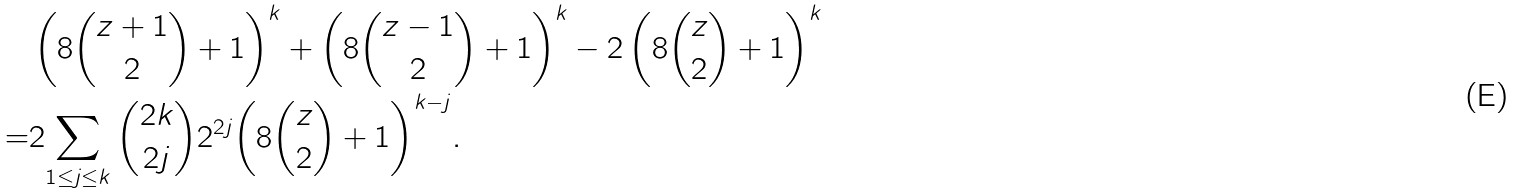Convert formula to latex. <formula><loc_0><loc_0><loc_500><loc_500>& \left ( 8 \binom { z + 1 } { 2 } + 1 \right ) ^ { k } + \left ( 8 \binom { z - 1 } { 2 } + 1 \right ) ^ { k } - 2 \left ( 8 \binom { z } { 2 } + 1 \right ) ^ { k } \\ = & 2 { \sum _ { 1 \leq j \leq { k } } \binom { 2 k } { 2 j } 2 ^ { 2 j } { \left ( 8 \binom { z } { 2 } + 1 \right ) } ^ { k - j } } .</formula> 